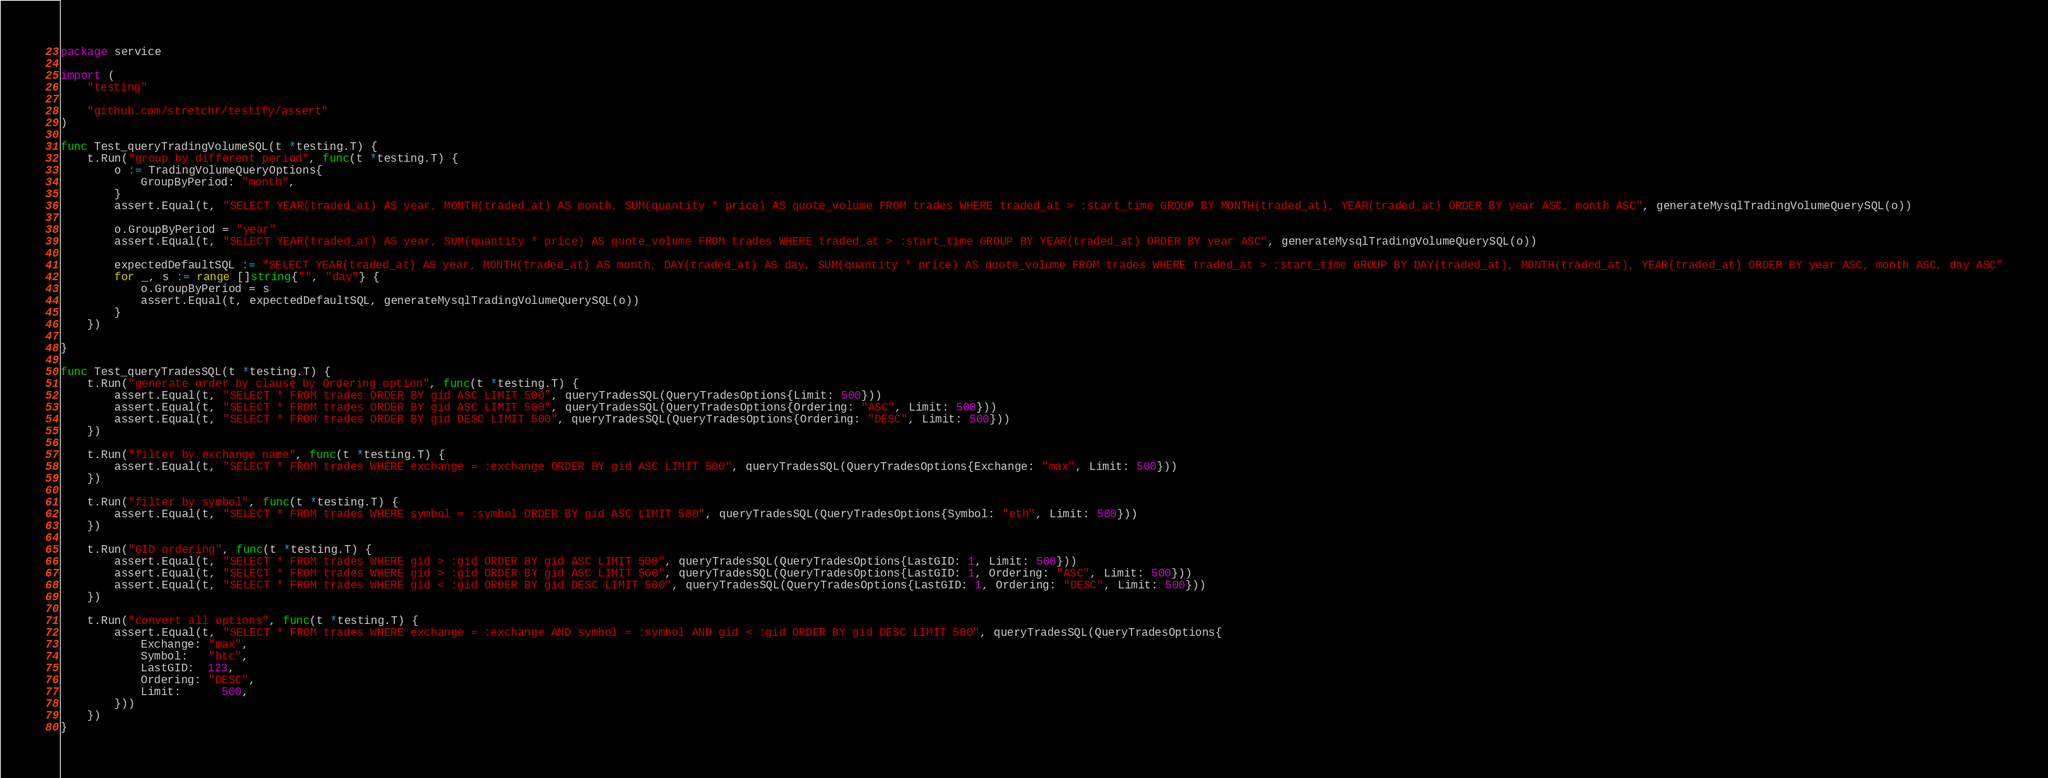<code> <loc_0><loc_0><loc_500><loc_500><_Go_>package service

import (
	"testing"

	"github.com/stretchr/testify/assert"
)

func Test_queryTradingVolumeSQL(t *testing.T) {
	t.Run("group by different period", func(t *testing.T) {
		o := TradingVolumeQueryOptions{
			GroupByPeriod: "month",
		}
		assert.Equal(t, "SELECT YEAR(traded_at) AS year, MONTH(traded_at) AS month, SUM(quantity * price) AS quote_volume FROM trades WHERE traded_at > :start_time GROUP BY MONTH(traded_at), YEAR(traded_at) ORDER BY year ASC, month ASC", generateMysqlTradingVolumeQuerySQL(o))

		o.GroupByPeriod = "year"
		assert.Equal(t, "SELECT YEAR(traded_at) AS year, SUM(quantity * price) AS quote_volume FROM trades WHERE traded_at > :start_time GROUP BY YEAR(traded_at) ORDER BY year ASC", generateMysqlTradingVolumeQuerySQL(o))

		expectedDefaultSQL := "SELECT YEAR(traded_at) AS year, MONTH(traded_at) AS month, DAY(traded_at) AS day, SUM(quantity * price) AS quote_volume FROM trades WHERE traded_at > :start_time GROUP BY DAY(traded_at), MONTH(traded_at), YEAR(traded_at) ORDER BY year ASC, month ASC, day ASC"
		for _, s := range []string{"", "day"} {
			o.GroupByPeriod = s
			assert.Equal(t, expectedDefaultSQL, generateMysqlTradingVolumeQuerySQL(o))
		}
	})

}

func Test_queryTradesSQL(t *testing.T) {
	t.Run("generate order by clause by Ordering option", func(t *testing.T) {
		assert.Equal(t, "SELECT * FROM trades ORDER BY gid ASC LIMIT 500", queryTradesSQL(QueryTradesOptions{Limit: 500}))
		assert.Equal(t, "SELECT * FROM trades ORDER BY gid ASC LIMIT 500", queryTradesSQL(QueryTradesOptions{Ordering: "ASC", Limit: 500}))
		assert.Equal(t, "SELECT * FROM trades ORDER BY gid DESC LIMIT 500", queryTradesSQL(QueryTradesOptions{Ordering: "DESC", Limit: 500}))
	})

	t.Run("filter by exchange name", func(t *testing.T) {
		assert.Equal(t, "SELECT * FROM trades WHERE exchange = :exchange ORDER BY gid ASC LIMIT 500", queryTradesSQL(QueryTradesOptions{Exchange: "max", Limit: 500}))
	})

	t.Run("filter by symbol", func(t *testing.T) {
		assert.Equal(t, "SELECT * FROM trades WHERE symbol = :symbol ORDER BY gid ASC LIMIT 500", queryTradesSQL(QueryTradesOptions{Symbol: "eth", Limit: 500}))
	})

	t.Run("GID ordering", func(t *testing.T) {
		assert.Equal(t, "SELECT * FROM trades WHERE gid > :gid ORDER BY gid ASC LIMIT 500", queryTradesSQL(QueryTradesOptions{LastGID: 1, Limit: 500}))
		assert.Equal(t, "SELECT * FROM trades WHERE gid > :gid ORDER BY gid ASC LIMIT 500", queryTradesSQL(QueryTradesOptions{LastGID: 1, Ordering: "ASC", Limit: 500}))
		assert.Equal(t, "SELECT * FROM trades WHERE gid < :gid ORDER BY gid DESC LIMIT 500", queryTradesSQL(QueryTradesOptions{LastGID: 1, Ordering: "DESC", Limit: 500}))
	})

	t.Run("convert all options", func(t *testing.T) {
		assert.Equal(t, "SELECT * FROM trades WHERE exchange = :exchange AND symbol = :symbol AND gid < :gid ORDER BY gid DESC LIMIT 500", queryTradesSQL(QueryTradesOptions{
			Exchange: "max",
			Symbol:   "btc",
			LastGID:  123,
			Ordering: "DESC",
			Limit:	  500,
		}))
	})
}
</code> 